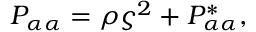Convert formula to latex. <formula><loc_0><loc_0><loc_500><loc_500>P _ { \alpha \alpha } = \rho \varsigma ^ { 2 } + P _ { \alpha \alpha } ^ { * } ,</formula> 